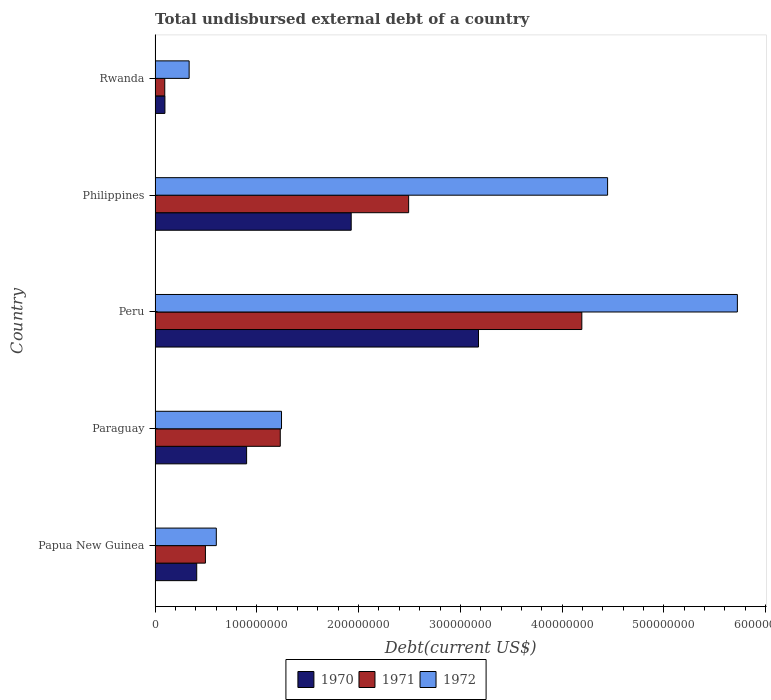How many groups of bars are there?
Keep it short and to the point. 5. Are the number of bars per tick equal to the number of legend labels?
Your answer should be very brief. Yes. Are the number of bars on each tick of the Y-axis equal?
Your response must be concise. Yes. How many bars are there on the 2nd tick from the top?
Your response must be concise. 3. How many bars are there on the 3rd tick from the bottom?
Provide a succinct answer. 3. What is the label of the 1st group of bars from the top?
Provide a succinct answer. Rwanda. In how many cases, is the number of bars for a given country not equal to the number of legend labels?
Provide a succinct answer. 0. What is the total undisbursed external debt in 1970 in Paraguay?
Give a very brief answer. 9.00e+07. Across all countries, what is the maximum total undisbursed external debt in 1971?
Your answer should be compact. 4.19e+08. Across all countries, what is the minimum total undisbursed external debt in 1971?
Your answer should be very brief. 9.53e+06. In which country was the total undisbursed external debt in 1972 maximum?
Your answer should be compact. Peru. In which country was the total undisbursed external debt in 1971 minimum?
Provide a short and direct response. Rwanda. What is the total total undisbursed external debt in 1971 in the graph?
Your answer should be very brief. 8.51e+08. What is the difference between the total undisbursed external debt in 1971 in Papua New Guinea and that in Paraguay?
Your answer should be very brief. -7.35e+07. What is the difference between the total undisbursed external debt in 1971 in Rwanda and the total undisbursed external debt in 1970 in Philippines?
Keep it short and to the point. -1.83e+08. What is the average total undisbursed external debt in 1971 per country?
Ensure brevity in your answer.  1.70e+08. What is the difference between the total undisbursed external debt in 1970 and total undisbursed external debt in 1971 in Peru?
Offer a terse response. -1.02e+08. In how many countries, is the total undisbursed external debt in 1970 greater than 300000000 US$?
Your answer should be very brief. 1. What is the ratio of the total undisbursed external debt in 1971 in Paraguay to that in Rwanda?
Provide a short and direct response. 12.91. Is the total undisbursed external debt in 1972 in Papua New Guinea less than that in Peru?
Offer a very short reply. Yes. Is the difference between the total undisbursed external debt in 1970 in Paraguay and Rwanda greater than the difference between the total undisbursed external debt in 1971 in Paraguay and Rwanda?
Provide a succinct answer. No. What is the difference between the highest and the second highest total undisbursed external debt in 1970?
Ensure brevity in your answer.  1.25e+08. What is the difference between the highest and the lowest total undisbursed external debt in 1970?
Ensure brevity in your answer.  3.08e+08. In how many countries, is the total undisbursed external debt in 1972 greater than the average total undisbursed external debt in 1972 taken over all countries?
Provide a succinct answer. 2. How many bars are there?
Make the answer very short. 15. How many countries are there in the graph?
Provide a succinct answer. 5. What is the difference between two consecutive major ticks on the X-axis?
Keep it short and to the point. 1.00e+08. Does the graph contain grids?
Ensure brevity in your answer.  No. Where does the legend appear in the graph?
Ensure brevity in your answer.  Bottom center. How many legend labels are there?
Provide a succinct answer. 3. How are the legend labels stacked?
Your response must be concise. Horizontal. What is the title of the graph?
Make the answer very short. Total undisbursed external debt of a country. What is the label or title of the X-axis?
Provide a succinct answer. Debt(current US$). What is the Debt(current US$) in 1970 in Papua New Guinea?
Offer a terse response. 4.09e+07. What is the Debt(current US$) of 1971 in Papua New Guinea?
Offer a very short reply. 4.95e+07. What is the Debt(current US$) of 1972 in Papua New Guinea?
Provide a succinct answer. 6.02e+07. What is the Debt(current US$) of 1970 in Paraguay?
Your answer should be very brief. 9.00e+07. What is the Debt(current US$) in 1971 in Paraguay?
Your answer should be very brief. 1.23e+08. What is the Debt(current US$) of 1972 in Paraguay?
Make the answer very short. 1.24e+08. What is the Debt(current US$) in 1970 in Peru?
Your response must be concise. 3.18e+08. What is the Debt(current US$) in 1971 in Peru?
Offer a terse response. 4.19e+08. What is the Debt(current US$) in 1972 in Peru?
Keep it short and to the point. 5.72e+08. What is the Debt(current US$) of 1970 in Philippines?
Make the answer very short. 1.93e+08. What is the Debt(current US$) in 1971 in Philippines?
Keep it short and to the point. 2.49e+08. What is the Debt(current US$) in 1972 in Philippines?
Provide a short and direct response. 4.45e+08. What is the Debt(current US$) of 1970 in Rwanda?
Make the answer very short. 9.70e+06. What is the Debt(current US$) in 1971 in Rwanda?
Provide a short and direct response. 9.53e+06. What is the Debt(current US$) in 1972 in Rwanda?
Offer a terse response. 3.35e+07. Across all countries, what is the maximum Debt(current US$) of 1970?
Your response must be concise. 3.18e+08. Across all countries, what is the maximum Debt(current US$) in 1971?
Provide a succinct answer. 4.19e+08. Across all countries, what is the maximum Debt(current US$) of 1972?
Provide a short and direct response. 5.72e+08. Across all countries, what is the minimum Debt(current US$) of 1970?
Provide a succinct answer. 9.70e+06. Across all countries, what is the minimum Debt(current US$) in 1971?
Ensure brevity in your answer.  9.53e+06. Across all countries, what is the minimum Debt(current US$) in 1972?
Your answer should be compact. 3.35e+07. What is the total Debt(current US$) of 1970 in the graph?
Offer a terse response. 6.51e+08. What is the total Debt(current US$) in 1971 in the graph?
Give a very brief answer. 8.51e+08. What is the total Debt(current US$) of 1972 in the graph?
Keep it short and to the point. 1.23e+09. What is the difference between the Debt(current US$) in 1970 in Papua New Guinea and that in Paraguay?
Ensure brevity in your answer.  -4.90e+07. What is the difference between the Debt(current US$) in 1971 in Papua New Guinea and that in Paraguay?
Provide a succinct answer. -7.35e+07. What is the difference between the Debt(current US$) of 1972 in Papua New Guinea and that in Paraguay?
Provide a short and direct response. -6.41e+07. What is the difference between the Debt(current US$) in 1970 in Papua New Guinea and that in Peru?
Your answer should be compact. -2.77e+08. What is the difference between the Debt(current US$) of 1971 in Papua New Guinea and that in Peru?
Keep it short and to the point. -3.70e+08. What is the difference between the Debt(current US$) of 1972 in Papua New Guinea and that in Peru?
Offer a very short reply. -5.12e+08. What is the difference between the Debt(current US$) in 1970 in Papua New Guinea and that in Philippines?
Keep it short and to the point. -1.52e+08. What is the difference between the Debt(current US$) of 1971 in Papua New Guinea and that in Philippines?
Offer a terse response. -2.00e+08. What is the difference between the Debt(current US$) of 1972 in Papua New Guinea and that in Philippines?
Provide a short and direct response. -3.84e+08. What is the difference between the Debt(current US$) in 1970 in Papua New Guinea and that in Rwanda?
Offer a very short reply. 3.12e+07. What is the difference between the Debt(current US$) of 1971 in Papua New Guinea and that in Rwanda?
Make the answer very short. 4.00e+07. What is the difference between the Debt(current US$) of 1972 in Papua New Guinea and that in Rwanda?
Provide a succinct answer. 2.67e+07. What is the difference between the Debt(current US$) in 1970 in Paraguay and that in Peru?
Your answer should be compact. -2.28e+08. What is the difference between the Debt(current US$) in 1971 in Paraguay and that in Peru?
Give a very brief answer. -2.96e+08. What is the difference between the Debt(current US$) in 1972 in Paraguay and that in Peru?
Ensure brevity in your answer.  -4.48e+08. What is the difference between the Debt(current US$) of 1970 in Paraguay and that in Philippines?
Provide a short and direct response. -1.03e+08. What is the difference between the Debt(current US$) of 1971 in Paraguay and that in Philippines?
Offer a very short reply. -1.26e+08. What is the difference between the Debt(current US$) of 1972 in Paraguay and that in Philippines?
Offer a very short reply. -3.20e+08. What is the difference between the Debt(current US$) in 1970 in Paraguay and that in Rwanda?
Keep it short and to the point. 8.03e+07. What is the difference between the Debt(current US$) of 1971 in Paraguay and that in Rwanda?
Your answer should be compact. 1.13e+08. What is the difference between the Debt(current US$) of 1972 in Paraguay and that in Rwanda?
Ensure brevity in your answer.  9.08e+07. What is the difference between the Debt(current US$) of 1970 in Peru and that in Philippines?
Provide a short and direct response. 1.25e+08. What is the difference between the Debt(current US$) in 1971 in Peru and that in Philippines?
Ensure brevity in your answer.  1.70e+08. What is the difference between the Debt(current US$) in 1972 in Peru and that in Philippines?
Your answer should be compact. 1.28e+08. What is the difference between the Debt(current US$) in 1970 in Peru and that in Rwanda?
Provide a short and direct response. 3.08e+08. What is the difference between the Debt(current US$) of 1971 in Peru and that in Rwanda?
Your answer should be compact. 4.10e+08. What is the difference between the Debt(current US$) of 1972 in Peru and that in Rwanda?
Your answer should be compact. 5.39e+08. What is the difference between the Debt(current US$) in 1970 in Philippines and that in Rwanda?
Ensure brevity in your answer.  1.83e+08. What is the difference between the Debt(current US$) of 1971 in Philippines and that in Rwanda?
Your answer should be compact. 2.40e+08. What is the difference between the Debt(current US$) of 1972 in Philippines and that in Rwanda?
Keep it short and to the point. 4.11e+08. What is the difference between the Debt(current US$) in 1970 in Papua New Guinea and the Debt(current US$) in 1971 in Paraguay?
Give a very brief answer. -8.21e+07. What is the difference between the Debt(current US$) in 1970 in Papua New Guinea and the Debt(current US$) in 1972 in Paraguay?
Offer a terse response. -8.33e+07. What is the difference between the Debt(current US$) of 1971 in Papua New Guinea and the Debt(current US$) of 1972 in Paraguay?
Give a very brief answer. -7.48e+07. What is the difference between the Debt(current US$) of 1970 in Papua New Guinea and the Debt(current US$) of 1971 in Peru?
Your answer should be compact. -3.78e+08. What is the difference between the Debt(current US$) of 1970 in Papua New Guinea and the Debt(current US$) of 1972 in Peru?
Make the answer very short. -5.31e+08. What is the difference between the Debt(current US$) of 1971 in Papua New Guinea and the Debt(current US$) of 1972 in Peru?
Your response must be concise. -5.23e+08. What is the difference between the Debt(current US$) of 1970 in Papua New Guinea and the Debt(current US$) of 1971 in Philippines?
Ensure brevity in your answer.  -2.08e+08. What is the difference between the Debt(current US$) of 1970 in Papua New Guinea and the Debt(current US$) of 1972 in Philippines?
Give a very brief answer. -4.04e+08. What is the difference between the Debt(current US$) in 1971 in Papua New Guinea and the Debt(current US$) in 1972 in Philippines?
Offer a terse response. -3.95e+08. What is the difference between the Debt(current US$) in 1970 in Papua New Guinea and the Debt(current US$) in 1971 in Rwanda?
Offer a very short reply. 3.14e+07. What is the difference between the Debt(current US$) of 1970 in Papua New Guinea and the Debt(current US$) of 1972 in Rwanda?
Your answer should be compact. 7.44e+06. What is the difference between the Debt(current US$) of 1971 in Papua New Guinea and the Debt(current US$) of 1972 in Rwanda?
Your response must be concise. 1.60e+07. What is the difference between the Debt(current US$) in 1970 in Paraguay and the Debt(current US$) in 1971 in Peru?
Your answer should be very brief. -3.29e+08. What is the difference between the Debt(current US$) in 1970 in Paraguay and the Debt(current US$) in 1972 in Peru?
Give a very brief answer. -4.82e+08. What is the difference between the Debt(current US$) in 1971 in Paraguay and the Debt(current US$) in 1972 in Peru?
Make the answer very short. -4.49e+08. What is the difference between the Debt(current US$) in 1970 in Paraguay and the Debt(current US$) in 1971 in Philippines?
Your response must be concise. -1.59e+08. What is the difference between the Debt(current US$) in 1970 in Paraguay and the Debt(current US$) in 1972 in Philippines?
Your answer should be compact. -3.55e+08. What is the difference between the Debt(current US$) in 1971 in Paraguay and the Debt(current US$) in 1972 in Philippines?
Your response must be concise. -3.22e+08. What is the difference between the Debt(current US$) in 1970 in Paraguay and the Debt(current US$) in 1971 in Rwanda?
Offer a terse response. 8.04e+07. What is the difference between the Debt(current US$) in 1970 in Paraguay and the Debt(current US$) in 1972 in Rwanda?
Your response must be concise. 5.65e+07. What is the difference between the Debt(current US$) in 1971 in Paraguay and the Debt(current US$) in 1972 in Rwanda?
Ensure brevity in your answer.  8.95e+07. What is the difference between the Debt(current US$) of 1970 in Peru and the Debt(current US$) of 1971 in Philippines?
Ensure brevity in your answer.  6.86e+07. What is the difference between the Debt(current US$) of 1970 in Peru and the Debt(current US$) of 1972 in Philippines?
Provide a short and direct response. -1.27e+08. What is the difference between the Debt(current US$) in 1971 in Peru and the Debt(current US$) in 1972 in Philippines?
Provide a succinct answer. -2.53e+07. What is the difference between the Debt(current US$) in 1970 in Peru and the Debt(current US$) in 1971 in Rwanda?
Ensure brevity in your answer.  3.08e+08. What is the difference between the Debt(current US$) of 1970 in Peru and the Debt(current US$) of 1972 in Rwanda?
Make the answer very short. 2.84e+08. What is the difference between the Debt(current US$) of 1971 in Peru and the Debt(current US$) of 1972 in Rwanda?
Your response must be concise. 3.86e+08. What is the difference between the Debt(current US$) of 1970 in Philippines and the Debt(current US$) of 1971 in Rwanda?
Give a very brief answer. 1.83e+08. What is the difference between the Debt(current US$) in 1970 in Philippines and the Debt(current US$) in 1972 in Rwanda?
Keep it short and to the point. 1.59e+08. What is the difference between the Debt(current US$) in 1971 in Philippines and the Debt(current US$) in 1972 in Rwanda?
Your response must be concise. 2.16e+08. What is the average Debt(current US$) of 1970 per country?
Provide a succinct answer. 1.30e+08. What is the average Debt(current US$) in 1971 per country?
Provide a succinct answer. 1.70e+08. What is the average Debt(current US$) in 1972 per country?
Provide a short and direct response. 2.47e+08. What is the difference between the Debt(current US$) in 1970 and Debt(current US$) in 1971 in Papua New Guinea?
Your answer should be compact. -8.56e+06. What is the difference between the Debt(current US$) of 1970 and Debt(current US$) of 1972 in Papua New Guinea?
Offer a terse response. -1.93e+07. What is the difference between the Debt(current US$) in 1971 and Debt(current US$) in 1972 in Papua New Guinea?
Your answer should be compact. -1.07e+07. What is the difference between the Debt(current US$) in 1970 and Debt(current US$) in 1971 in Paraguay?
Provide a short and direct response. -3.31e+07. What is the difference between the Debt(current US$) in 1970 and Debt(current US$) in 1972 in Paraguay?
Your response must be concise. -3.43e+07. What is the difference between the Debt(current US$) in 1971 and Debt(current US$) in 1972 in Paraguay?
Your response must be concise. -1.22e+06. What is the difference between the Debt(current US$) of 1970 and Debt(current US$) of 1971 in Peru?
Provide a succinct answer. -1.02e+08. What is the difference between the Debt(current US$) of 1970 and Debt(current US$) of 1972 in Peru?
Give a very brief answer. -2.54e+08. What is the difference between the Debt(current US$) in 1971 and Debt(current US$) in 1972 in Peru?
Provide a succinct answer. -1.53e+08. What is the difference between the Debt(current US$) in 1970 and Debt(current US$) in 1971 in Philippines?
Provide a succinct answer. -5.64e+07. What is the difference between the Debt(current US$) in 1970 and Debt(current US$) in 1972 in Philippines?
Provide a short and direct response. -2.52e+08. What is the difference between the Debt(current US$) of 1971 and Debt(current US$) of 1972 in Philippines?
Make the answer very short. -1.95e+08. What is the difference between the Debt(current US$) in 1970 and Debt(current US$) in 1971 in Rwanda?
Your answer should be compact. 1.63e+05. What is the difference between the Debt(current US$) of 1970 and Debt(current US$) of 1972 in Rwanda?
Give a very brief answer. -2.38e+07. What is the difference between the Debt(current US$) in 1971 and Debt(current US$) in 1972 in Rwanda?
Ensure brevity in your answer.  -2.40e+07. What is the ratio of the Debt(current US$) in 1970 in Papua New Guinea to that in Paraguay?
Keep it short and to the point. 0.46. What is the ratio of the Debt(current US$) in 1971 in Papua New Guinea to that in Paraguay?
Provide a short and direct response. 0.4. What is the ratio of the Debt(current US$) of 1972 in Papua New Guinea to that in Paraguay?
Your answer should be very brief. 0.48. What is the ratio of the Debt(current US$) in 1970 in Papua New Guinea to that in Peru?
Keep it short and to the point. 0.13. What is the ratio of the Debt(current US$) in 1971 in Papua New Guinea to that in Peru?
Your answer should be compact. 0.12. What is the ratio of the Debt(current US$) in 1972 in Papua New Guinea to that in Peru?
Keep it short and to the point. 0.11. What is the ratio of the Debt(current US$) of 1970 in Papua New Guinea to that in Philippines?
Make the answer very short. 0.21. What is the ratio of the Debt(current US$) of 1971 in Papua New Guinea to that in Philippines?
Keep it short and to the point. 0.2. What is the ratio of the Debt(current US$) in 1972 in Papua New Guinea to that in Philippines?
Your response must be concise. 0.14. What is the ratio of the Debt(current US$) of 1970 in Papua New Guinea to that in Rwanda?
Give a very brief answer. 4.22. What is the ratio of the Debt(current US$) in 1971 in Papua New Guinea to that in Rwanda?
Your response must be concise. 5.19. What is the ratio of the Debt(current US$) in 1972 in Papua New Guinea to that in Rwanda?
Provide a short and direct response. 1.8. What is the ratio of the Debt(current US$) in 1970 in Paraguay to that in Peru?
Your answer should be compact. 0.28. What is the ratio of the Debt(current US$) in 1971 in Paraguay to that in Peru?
Ensure brevity in your answer.  0.29. What is the ratio of the Debt(current US$) of 1972 in Paraguay to that in Peru?
Keep it short and to the point. 0.22. What is the ratio of the Debt(current US$) in 1970 in Paraguay to that in Philippines?
Your answer should be very brief. 0.47. What is the ratio of the Debt(current US$) of 1971 in Paraguay to that in Philippines?
Give a very brief answer. 0.49. What is the ratio of the Debt(current US$) of 1972 in Paraguay to that in Philippines?
Your answer should be very brief. 0.28. What is the ratio of the Debt(current US$) in 1970 in Paraguay to that in Rwanda?
Your response must be concise. 9.28. What is the ratio of the Debt(current US$) in 1971 in Paraguay to that in Rwanda?
Your answer should be very brief. 12.91. What is the ratio of the Debt(current US$) of 1972 in Paraguay to that in Rwanda?
Give a very brief answer. 3.71. What is the ratio of the Debt(current US$) in 1970 in Peru to that in Philippines?
Provide a succinct answer. 1.65. What is the ratio of the Debt(current US$) of 1971 in Peru to that in Philippines?
Your response must be concise. 1.68. What is the ratio of the Debt(current US$) in 1972 in Peru to that in Philippines?
Provide a short and direct response. 1.29. What is the ratio of the Debt(current US$) of 1970 in Peru to that in Rwanda?
Ensure brevity in your answer.  32.78. What is the ratio of the Debt(current US$) in 1971 in Peru to that in Rwanda?
Provide a succinct answer. 43.99. What is the ratio of the Debt(current US$) in 1972 in Peru to that in Rwanda?
Your answer should be compact. 17.08. What is the ratio of the Debt(current US$) of 1970 in Philippines to that in Rwanda?
Provide a short and direct response. 19.88. What is the ratio of the Debt(current US$) in 1971 in Philippines to that in Rwanda?
Make the answer very short. 26.14. What is the ratio of the Debt(current US$) of 1972 in Philippines to that in Rwanda?
Offer a very short reply. 13.28. What is the difference between the highest and the second highest Debt(current US$) in 1970?
Offer a terse response. 1.25e+08. What is the difference between the highest and the second highest Debt(current US$) in 1971?
Your response must be concise. 1.70e+08. What is the difference between the highest and the second highest Debt(current US$) in 1972?
Ensure brevity in your answer.  1.28e+08. What is the difference between the highest and the lowest Debt(current US$) in 1970?
Give a very brief answer. 3.08e+08. What is the difference between the highest and the lowest Debt(current US$) of 1971?
Ensure brevity in your answer.  4.10e+08. What is the difference between the highest and the lowest Debt(current US$) of 1972?
Make the answer very short. 5.39e+08. 